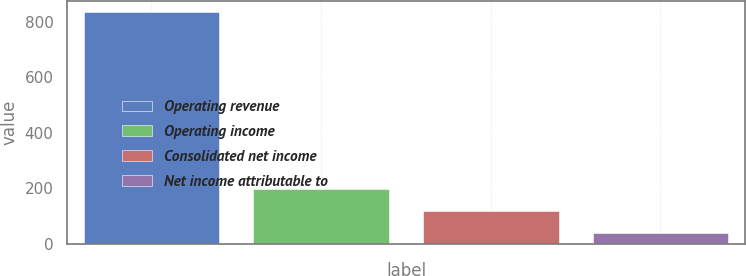Convert chart to OTSL. <chart><loc_0><loc_0><loc_500><loc_500><bar_chart><fcel>Operating revenue<fcel>Operating income<fcel>Consolidated net income<fcel>Net income attributable to<nl><fcel>834.2<fcel>197.56<fcel>117.98<fcel>38.4<nl></chart> 